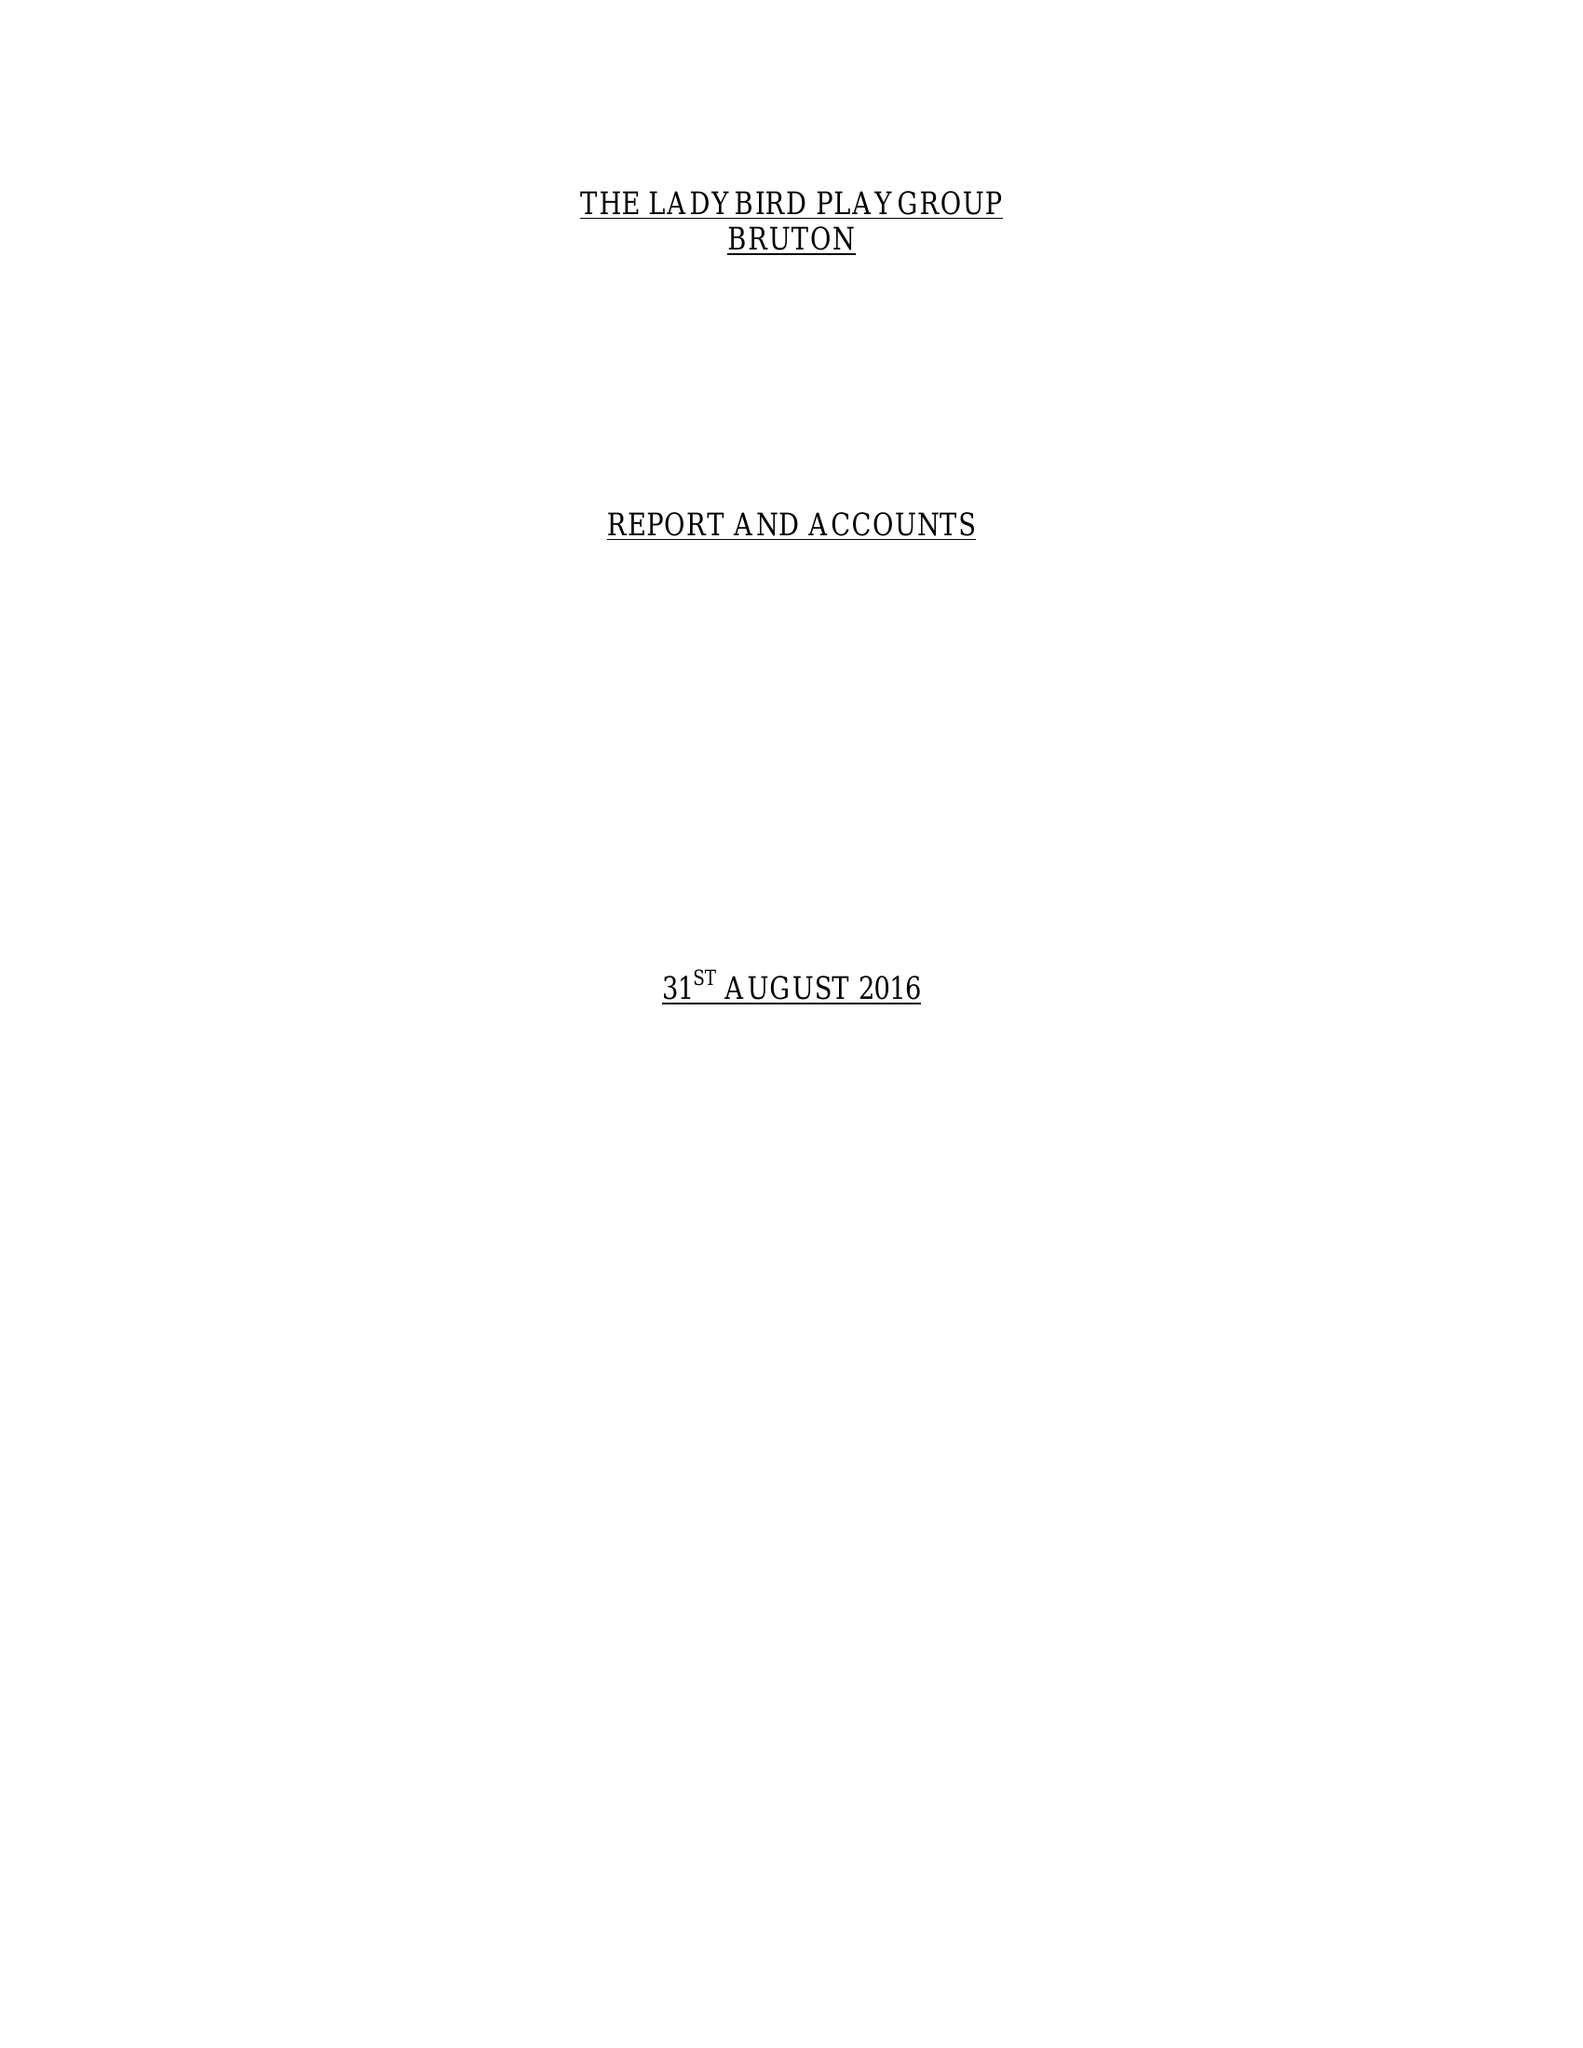What is the value for the address__postcode?
Answer the question using a single word or phrase. BA10  